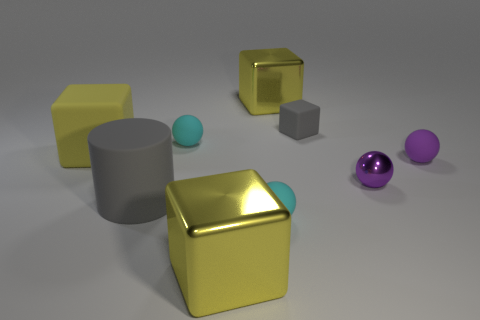Is there any other thing that has the same size as the gray cylinder?
Ensure brevity in your answer.  Yes. Are there any large gray rubber things on the left side of the large gray matte object in front of the gray block?
Your response must be concise. No. What number of things are right of the large yellow rubber block and behind the large gray thing?
Offer a terse response. 5. The small thing in front of the large matte cylinder has what shape?
Provide a succinct answer. Sphere. What number of shiny blocks are the same size as the gray cylinder?
Make the answer very short. 2. There is a small matte sphere behind the large matte cube; does it have the same color as the big cylinder?
Offer a very short reply. No. There is a big thing that is both to the right of the big gray object and in front of the small purple rubber thing; what material is it?
Keep it short and to the point. Metal. Are there more things than yellow matte blocks?
Your answer should be compact. Yes. The large metallic cube that is behind the cyan matte thing that is in front of the cyan thing that is behind the tiny purple shiny ball is what color?
Offer a terse response. Yellow. Do the thing behind the small matte block and the gray cube have the same material?
Your answer should be compact. No. 